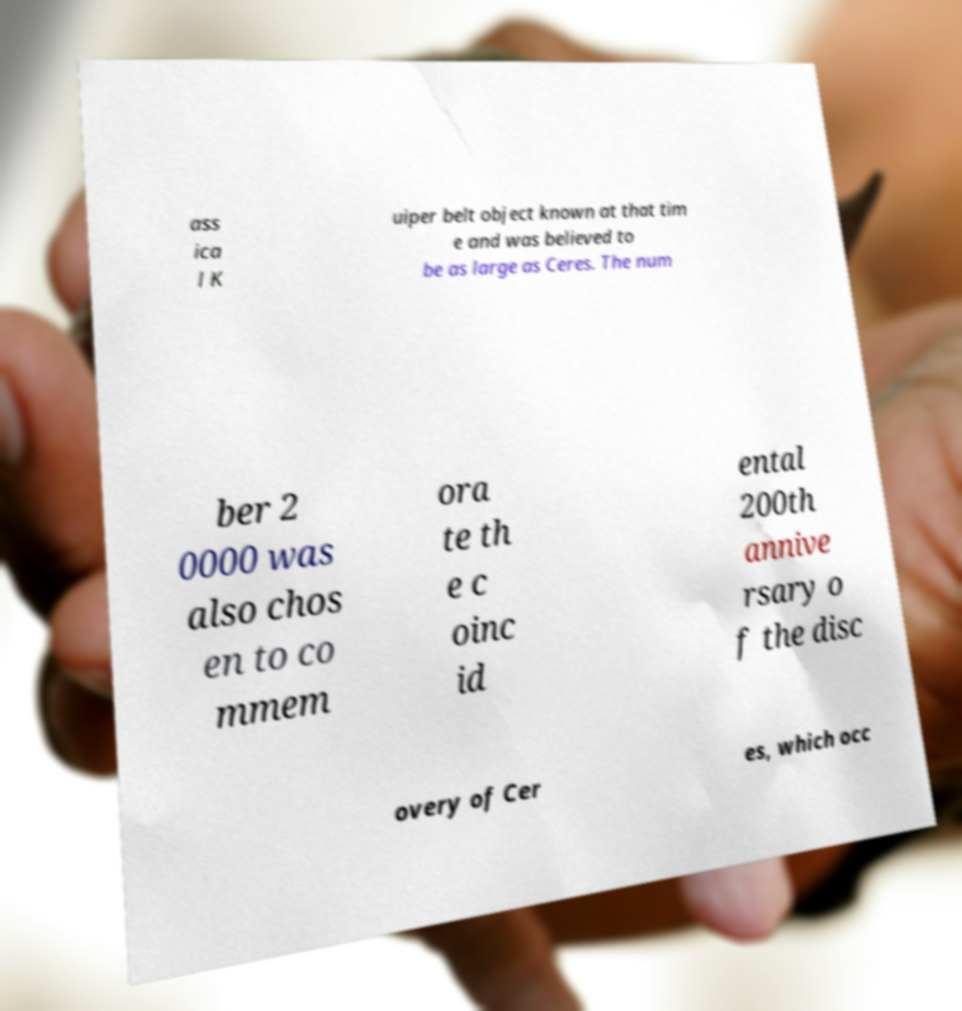What messages or text are displayed in this image? I need them in a readable, typed format. ass ica l K uiper belt object known at that tim e and was believed to be as large as Ceres. The num ber 2 0000 was also chos en to co mmem ora te th e c oinc id ental 200th annive rsary o f the disc overy of Cer es, which occ 